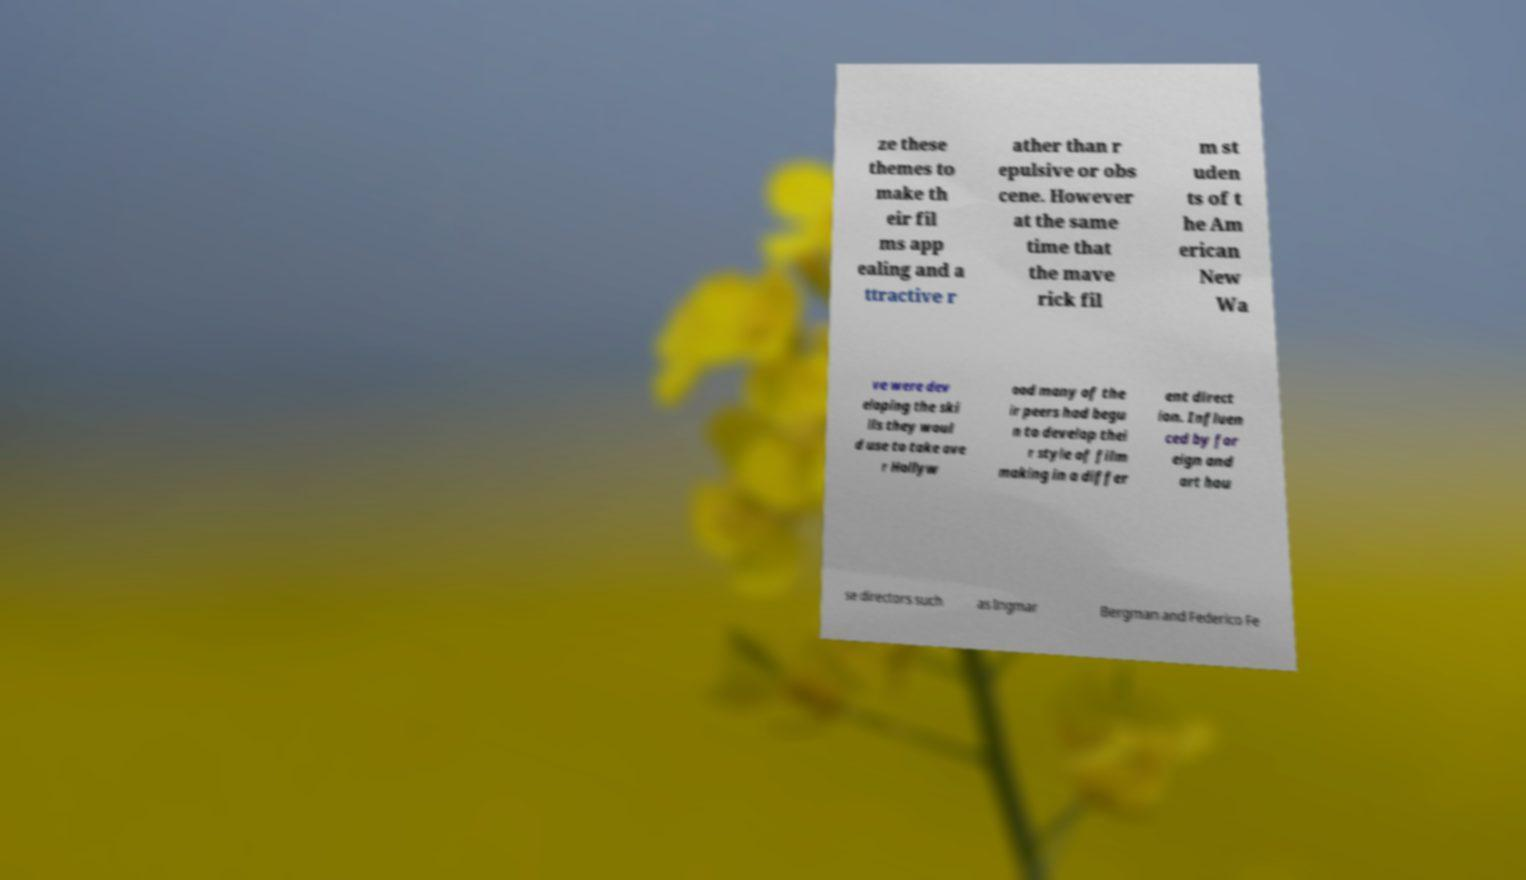Could you assist in decoding the text presented in this image and type it out clearly? ze these themes to make th eir fil ms app ealing and a ttractive r ather than r epulsive or obs cene. However at the same time that the mave rick fil m st uden ts of t he Am erican New Wa ve were dev eloping the ski lls they woul d use to take ove r Hollyw ood many of the ir peers had begu n to develop thei r style of film making in a differ ent direct ion. Influen ced by for eign and art hou se directors such as Ingmar Bergman and Federico Fe 